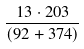<formula> <loc_0><loc_0><loc_500><loc_500>\frac { 1 3 \cdot 2 0 3 } { ( 9 2 + 3 7 4 ) }</formula> 